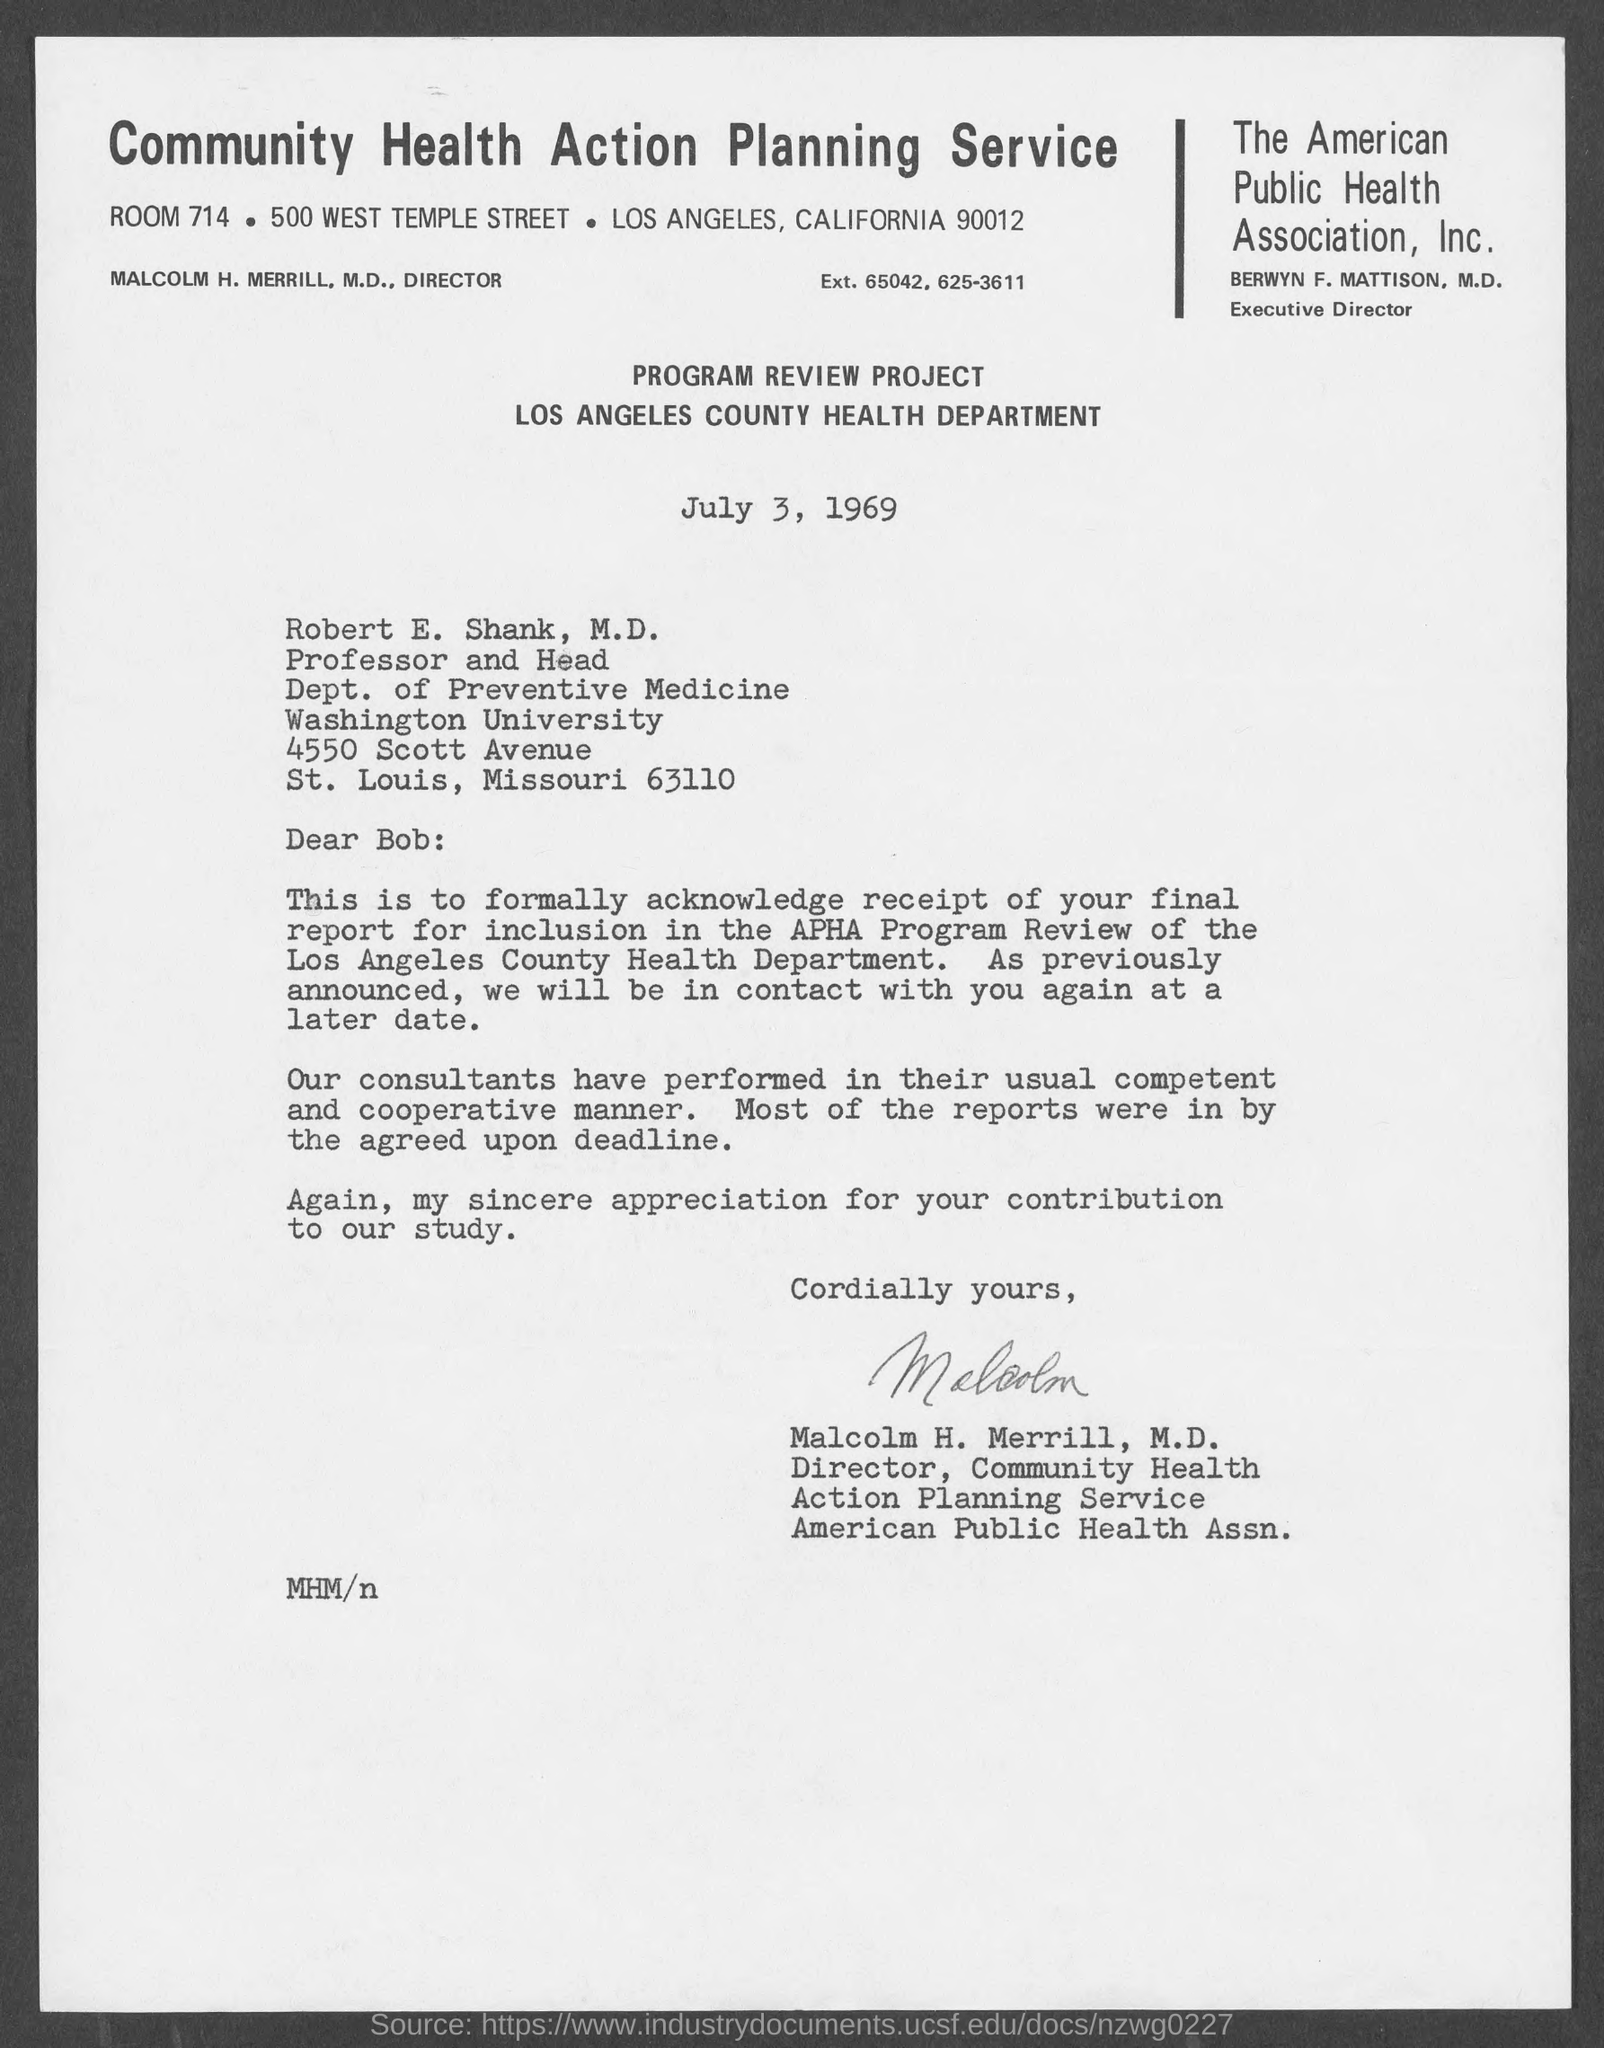List a handful of essential elements in this visual. The person who wrote this letter is Malcolm H. Merrill, M.D. The Director of Community Health Action Planning Service is Malcolm H. Merrill, M.D. The executive director of The Public Health Association, Inc. is Berwyn F. Mattison, M.D. I am requesting information about the postal code of California, specifically the code for the location 90012. The Professor and Head of the Department of Preventive Medicine is Robert E. Shank, M.D. 